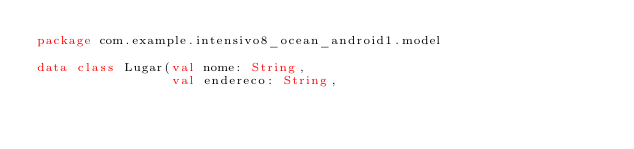Convert code to text. <code><loc_0><loc_0><loc_500><loc_500><_Kotlin_>package com.example.intensivo8_ocean_android1.model

data class Lugar(val nome: String,
                 val endereco: String,</code> 